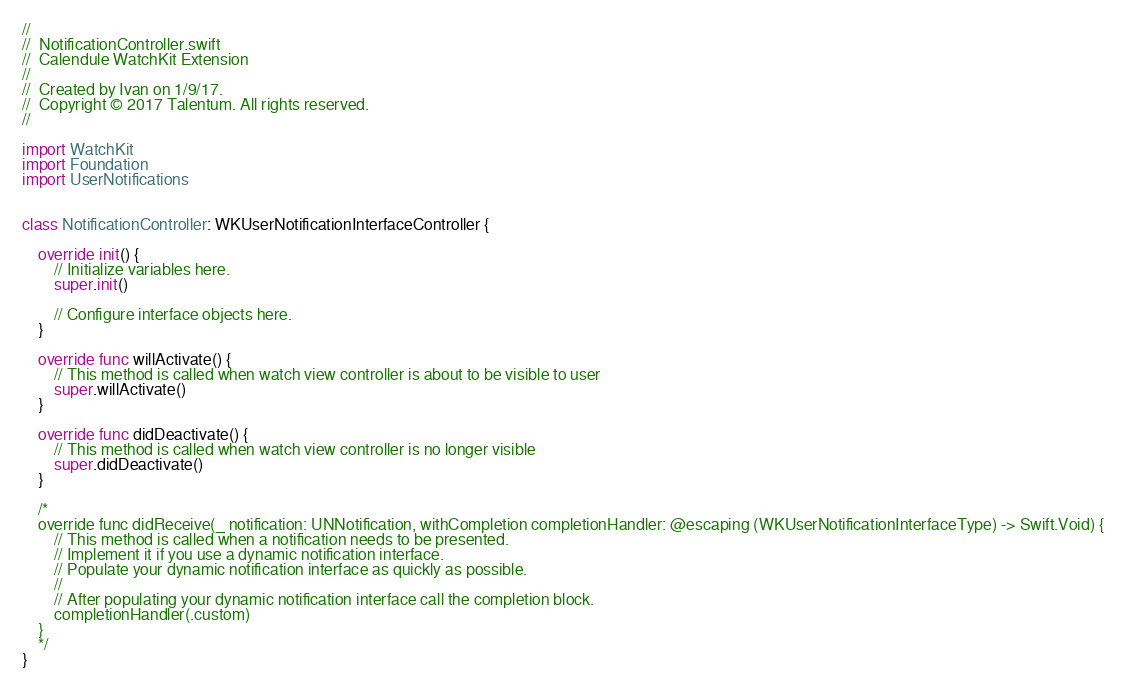<code> <loc_0><loc_0><loc_500><loc_500><_Swift_>//
//  NotificationController.swift
//  Calendule WatchKit Extension
//
//  Created by Ivan on 1/9/17.
//  Copyright © 2017 Talentum. All rights reserved.
//

import WatchKit
import Foundation
import UserNotifications


class NotificationController: WKUserNotificationInterfaceController {

    override init() {
        // Initialize variables here.
        super.init()
        
        // Configure interface objects here.
    }

    override func willActivate() {
        // This method is called when watch view controller is about to be visible to user
        super.willActivate()
    }

    override func didDeactivate() {
        // This method is called when watch view controller is no longer visible
        super.didDeactivate()
    }

    /*
    override func didReceive(_ notification: UNNotification, withCompletion completionHandler: @escaping (WKUserNotificationInterfaceType) -> Swift.Void) {
        // This method is called when a notification needs to be presented.
        // Implement it if you use a dynamic notification interface.
        // Populate your dynamic notification interface as quickly as possible.
        //
        // After populating your dynamic notification interface call the completion block.
        completionHandler(.custom)
    }
    */
}
</code> 